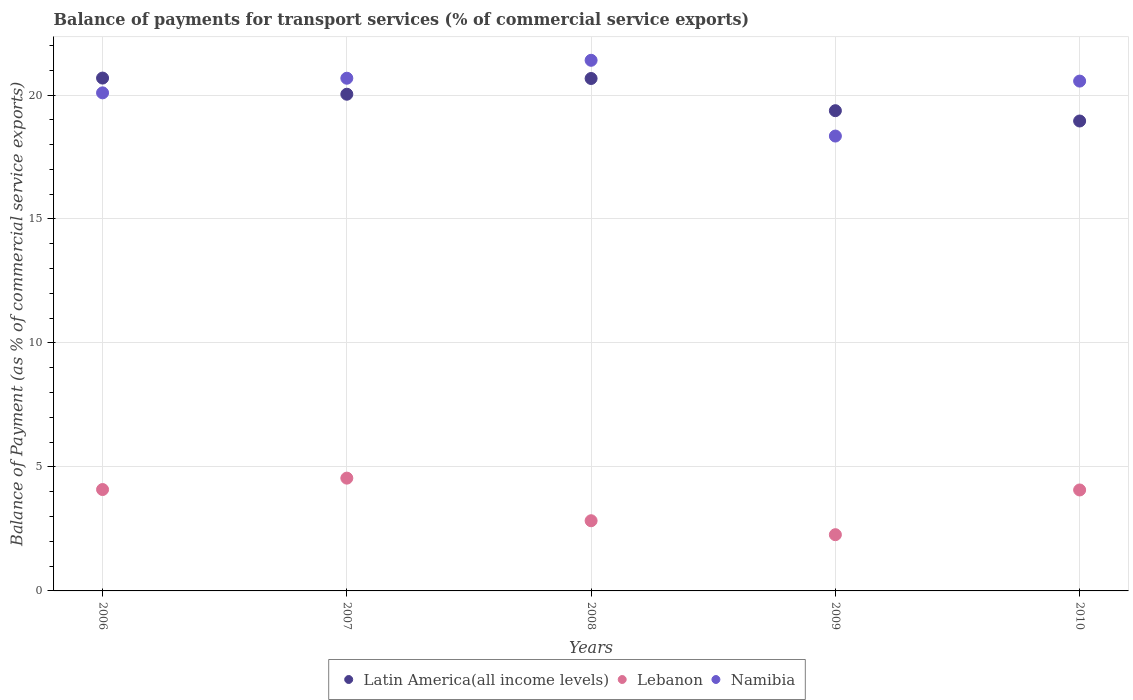Is the number of dotlines equal to the number of legend labels?
Your answer should be very brief. Yes. What is the balance of payments for transport services in Namibia in 2010?
Make the answer very short. 20.56. Across all years, what is the maximum balance of payments for transport services in Namibia?
Offer a terse response. 21.4. Across all years, what is the minimum balance of payments for transport services in Namibia?
Ensure brevity in your answer.  18.34. In which year was the balance of payments for transport services in Lebanon maximum?
Your response must be concise. 2007. In which year was the balance of payments for transport services in Namibia minimum?
Make the answer very short. 2009. What is the total balance of payments for transport services in Namibia in the graph?
Your answer should be very brief. 101.07. What is the difference between the balance of payments for transport services in Lebanon in 2008 and that in 2009?
Offer a terse response. 0.56. What is the difference between the balance of payments for transport services in Lebanon in 2007 and the balance of payments for transport services in Latin America(all income levels) in 2008?
Offer a very short reply. -16.12. What is the average balance of payments for transport services in Namibia per year?
Ensure brevity in your answer.  20.21. In the year 2010, what is the difference between the balance of payments for transport services in Namibia and balance of payments for transport services in Latin America(all income levels)?
Ensure brevity in your answer.  1.61. What is the ratio of the balance of payments for transport services in Namibia in 2006 to that in 2008?
Give a very brief answer. 0.94. Is the difference between the balance of payments for transport services in Namibia in 2008 and 2010 greater than the difference between the balance of payments for transport services in Latin America(all income levels) in 2008 and 2010?
Offer a terse response. No. What is the difference between the highest and the second highest balance of payments for transport services in Latin America(all income levels)?
Your answer should be very brief. 0.02. What is the difference between the highest and the lowest balance of payments for transport services in Lebanon?
Keep it short and to the point. 2.28. Does the balance of payments for transport services in Latin America(all income levels) monotonically increase over the years?
Your answer should be compact. No. Is the balance of payments for transport services in Namibia strictly greater than the balance of payments for transport services in Lebanon over the years?
Keep it short and to the point. Yes. Is the balance of payments for transport services in Namibia strictly less than the balance of payments for transport services in Latin America(all income levels) over the years?
Your response must be concise. No. How many dotlines are there?
Provide a succinct answer. 3. How many years are there in the graph?
Offer a terse response. 5. Does the graph contain any zero values?
Your response must be concise. No. Where does the legend appear in the graph?
Provide a short and direct response. Bottom center. How many legend labels are there?
Provide a succinct answer. 3. What is the title of the graph?
Your response must be concise. Balance of payments for transport services (% of commercial service exports). Does "Hong Kong" appear as one of the legend labels in the graph?
Give a very brief answer. No. What is the label or title of the X-axis?
Your answer should be very brief. Years. What is the label or title of the Y-axis?
Ensure brevity in your answer.  Balance of Payment (as % of commercial service exports). What is the Balance of Payment (as % of commercial service exports) in Latin America(all income levels) in 2006?
Your answer should be very brief. 20.68. What is the Balance of Payment (as % of commercial service exports) in Lebanon in 2006?
Ensure brevity in your answer.  4.09. What is the Balance of Payment (as % of commercial service exports) of Namibia in 2006?
Provide a succinct answer. 20.09. What is the Balance of Payment (as % of commercial service exports) of Latin America(all income levels) in 2007?
Your answer should be very brief. 20.03. What is the Balance of Payment (as % of commercial service exports) of Lebanon in 2007?
Keep it short and to the point. 4.55. What is the Balance of Payment (as % of commercial service exports) in Namibia in 2007?
Your response must be concise. 20.68. What is the Balance of Payment (as % of commercial service exports) of Latin America(all income levels) in 2008?
Your answer should be compact. 20.67. What is the Balance of Payment (as % of commercial service exports) in Lebanon in 2008?
Offer a very short reply. 2.83. What is the Balance of Payment (as % of commercial service exports) of Namibia in 2008?
Your answer should be compact. 21.4. What is the Balance of Payment (as % of commercial service exports) of Latin America(all income levels) in 2009?
Offer a very short reply. 19.37. What is the Balance of Payment (as % of commercial service exports) of Lebanon in 2009?
Your response must be concise. 2.27. What is the Balance of Payment (as % of commercial service exports) in Namibia in 2009?
Your answer should be compact. 18.34. What is the Balance of Payment (as % of commercial service exports) of Latin America(all income levels) in 2010?
Provide a succinct answer. 18.95. What is the Balance of Payment (as % of commercial service exports) of Lebanon in 2010?
Keep it short and to the point. 4.07. What is the Balance of Payment (as % of commercial service exports) of Namibia in 2010?
Provide a succinct answer. 20.56. Across all years, what is the maximum Balance of Payment (as % of commercial service exports) of Latin America(all income levels)?
Provide a succinct answer. 20.68. Across all years, what is the maximum Balance of Payment (as % of commercial service exports) in Lebanon?
Your response must be concise. 4.55. Across all years, what is the maximum Balance of Payment (as % of commercial service exports) of Namibia?
Your answer should be compact. 21.4. Across all years, what is the minimum Balance of Payment (as % of commercial service exports) in Latin America(all income levels)?
Make the answer very short. 18.95. Across all years, what is the minimum Balance of Payment (as % of commercial service exports) in Lebanon?
Your response must be concise. 2.27. Across all years, what is the minimum Balance of Payment (as % of commercial service exports) of Namibia?
Your response must be concise. 18.34. What is the total Balance of Payment (as % of commercial service exports) of Latin America(all income levels) in the graph?
Your answer should be compact. 99.7. What is the total Balance of Payment (as % of commercial service exports) in Lebanon in the graph?
Provide a short and direct response. 17.81. What is the total Balance of Payment (as % of commercial service exports) of Namibia in the graph?
Provide a succinct answer. 101.07. What is the difference between the Balance of Payment (as % of commercial service exports) of Latin America(all income levels) in 2006 and that in 2007?
Your answer should be very brief. 0.65. What is the difference between the Balance of Payment (as % of commercial service exports) in Lebanon in 2006 and that in 2007?
Ensure brevity in your answer.  -0.46. What is the difference between the Balance of Payment (as % of commercial service exports) of Namibia in 2006 and that in 2007?
Your answer should be very brief. -0.59. What is the difference between the Balance of Payment (as % of commercial service exports) of Latin America(all income levels) in 2006 and that in 2008?
Your answer should be compact. 0.02. What is the difference between the Balance of Payment (as % of commercial service exports) in Lebanon in 2006 and that in 2008?
Offer a terse response. 1.26. What is the difference between the Balance of Payment (as % of commercial service exports) in Namibia in 2006 and that in 2008?
Your answer should be compact. -1.31. What is the difference between the Balance of Payment (as % of commercial service exports) in Latin America(all income levels) in 2006 and that in 2009?
Your answer should be compact. 1.32. What is the difference between the Balance of Payment (as % of commercial service exports) in Lebanon in 2006 and that in 2009?
Make the answer very short. 1.82. What is the difference between the Balance of Payment (as % of commercial service exports) of Namibia in 2006 and that in 2009?
Provide a short and direct response. 1.74. What is the difference between the Balance of Payment (as % of commercial service exports) in Latin America(all income levels) in 2006 and that in 2010?
Offer a terse response. 1.73. What is the difference between the Balance of Payment (as % of commercial service exports) in Lebanon in 2006 and that in 2010?
Offer a very short reply. 0.02. What is the difference between the Balance of Payment (as % of commercial service exports) in Namibia in 2006 and that in 2010?
Your response must be concise. -0.47. What is the difference between the Balance of Payment (as % of commercial service exports) of Latin America(all income levels) in 2007 and that in 2008?
Provide a succinct answer. -0.63. What is the difference between the Balance of Payment (as % of commercial service exports) in Lebanon in 2007 and that in 2008?
Your response must be concise. 1.72. What is the difference between the Balance of Payment (as % of commercial service exports) in Namibia in 2007 and that in 2008?
Ensure brevity in your answer.  -0.72. What is the difference between the Balance of Payment (as % of commercial service exports) in Latin America(all income levels) in 2007 and that in 2009?
Ensure brevity in your answer.  0.66. What is the difference between the Balance of Payment (as % of commercial service exports) in Lebanon in 2007 and that in 2009?
Ensure brevity in your answer.  2.28. What is the difference between the Balance of Payment (as % of commercial service exports) in Namibia in 2007 and that in 2009?
Your response must be concise. 2.33. What is the difference between the Balance of Payment (as % of commercial service exports) of Latin America(all income levels) in 2007 and that in 2010?
Offer a terse response. 1.08. What is the difference between the Balance of Payment (as % of commercial service exports) of Lebanon in 2007 and that in 2010?
Provide a succinct answer. 0.48. What is the difference between the Balance of Payment (as % of commercial service exports) in Namibia in 2007 and that in 2010?
Ensure brevity in your answer.  0.12. What is the difference between the Balance of Payment (as % of commercial service exports) in Latin America(all income levels) in 2008 and that in 2009?
Keep it short and to the point. 1.3. What is the difference between the Balance of Payment (as % of commercial service exports) in Lebanon in 2008 and that in 2009?
Provide a succinct answer. 0.56. What is the difference between the Balance of Payment (as % of commercial service exports) of Namibia in 2008 and that in 2009?
Offer a very short reply. 3.06. What is the difference between the Balance of Payment (as % of commercial service exports) of Latin America(all income levels) in 2008 and that in 2010?
Your response must be concise. 1.71. What is the difference between the Balance of Payment (as % of commercial service exports) of Lebanon in 2008 and that in 2010?
Provide a short and direct response. -1.24. What is the difference between the Balance of Payment (as % of commercial service exports) in Namibia in 2008 and that in 2010?
Offer a very short reply. 0.84. What is the difference between the Balance of Payment (as % of commercial service exports) of Latin America(all income levels) in 2009 and that in 2010?
Your answer should be very brief. 0.42. What is the difference between the Balance of Payment (as % of commercial service exports) of Lebanon in 2009 and that in 2010?
Offer a terse response. -1.8. What is the difference between the Balance of Payment (as % of commercial service exports) of Namibia in 2009 and that in 2010?
Your response must be concise. -2.22. What is the difference between the Balance of Payment (as % of commercial service exports) of Latin America(all income levels) in 2006 and the Balance of Payment (as % of commercial service exports) of Lebanon in 2007?
Keep it short and to the point. 16.13. What is the difference between the Balance of Payment (as % of commercial service exports) in Latin America(all income levels) in 2006 and the Balance of Payment (as % of commercial service exports) in Namibia in 2007?
Your answer should be very brief. 0.01. What is the difference between the Balance of Payment (as % of commercial service exports) of Lebanon in 2006 and the Balance of Payment (as % of commercial service exports) of Namibia in 2007?
Your answer should be very brief. -16.59. What is the difference between the Balance of Payment (as % of commercial service exports) in Latin America(all income levels) in 2006 and the Balance of Payment (as % of commercial service exports) in Lebanon in 2008?
Keep it short and to the point. 17.85. What is the difference between the Balance of Payment (as % of commercial service exports) of Latin America(all income levels) in 2006 and the Balance of Payment (as % of commercial service exports) of Namibia in 2008?
Keep it short and to the point. -0.72. What is the difference between the Balance of Payment (as % of commercial service exports) of Lebanon in 2006 and the Balance of Payment (as % of commercial service exports) of Namibia in 2008?
Ensure brevity in your answer.  -17.31. What is the difference between the Balance of Payment (as % of commercial service exports) in Latin America(all income levels) in 2006 and the Balance of Payment (as % of commercial service exports) in Lebanon in 2009?
Make the answer very short. 18.42. What is the difference between the Balance of Payment (as % of commercial service exports) of Latin America(all income levels) in 2006 and the Balance of Payment (as % of commercial service exports) of Namibia in 2009?
Keep it short and to the point. 2.34. What is the difference between the Balance of Payment (as % of commercial service exports) in Lebanon in 2006 and the Balance of Payment (as % of commercial service exports) in Namibia in 2009?
Your response must be concise. -14.26. What is the difference between the Balance of Payment (as % of commercial service exports) of Latin America(all income levels) in 2006 and the Balance of Payment (as % of commercial service exports) of Lebanon in 2010?
Your response must be concise. 16.61. What is the difference between the Balance of Payment (as % of commercial service exports) in Latin America(all income levels) in 2006 and the Balance of Payment (as % of commercial service exports) in Namibia in 2010?
Your answer should be very brief. 0.12. What is the difference between the Balance of Payment (as % of commercial service exports) of Lebanon in 2006 and the Balance of Payment (as % of commercial service exports) of Namibia in 2010?
Your response must be concise. -16.47. What is the difference between the Balance of Payment (as % of commercial service exports) of Latin America(all income levels) in 2007 and the Balance of Payment (as % of commercial service exports) of Lebanon in 2008?
Your response must be concise. 17.2. What is the difference between the Balance of Payment (as % of commercial service exports) in Latin America(all income levels) in 2007 and the Balance of Payment (as % of commercial service exports) in Namibia in 2008?
Ensure brevity in your answer.  -1.37. What is the difference between the Balance of Payment (as % of commercial service exports) of Lebanon in 2007 and the Balance of Payment (as % of commercial service exports) of Namibia in 2008?
Offer a very short reply. -16.85. What is the difference between the Balance of Payment (as % of commercial service exports) in Latin America(all income levels) in 2007 and the Balance of Payment (as % of commercial service exports) in Lebanon in 2009?
Offer a very short reply. 17.76. What is the difference between the Balance of Payment (as % of commercial service exports) in Latin America(all income levels) in 2007 and the Balance of Payment (as % of commercial service exports) in Namibia in 2009?
Give a very brief answer. 1.69. What is the difference between the Balance of Payment (as % of commercial service exports) in Lebanon in 2007 and the Balance of Payment (as % of commercial service exports) in Namibia in 2009?
Keep it short and to the point. -13.8. What is the difference between the Balance of Payment (as % of commercial service exports) of Latin America(all income levels) in 2007 and the Balance of Payment (as % of commercial service exports) of Lebanon in 2010?
Ensure brevity in your answer.  15.96. What is the difference between the Balance of Payment (as % of commercial service exports) of Latin America(all income levels) in 2007 and the Balance of Payment (as % of commercial service exports) of Namibia in 2010?
Your answer should be very brief. -0.53. What is the difference between the Balance of Payment (as % of commercial service exports) of Lebanon in 2007 and the Balance of Payment (as % of commercial service exports) of Namibia in 2010?
Your response must be concise. -16.01. What is the difference between the Balance of Payment (as % of commercial service exports) of Latin America(all income levels) in 2008 and the Balance of Payment (as % of commercial service exports) of Lebanon in 2009?
Your response must be concise. 18.4. What is the difference between the Balance of Payment (as % of commercial service exports) in Latin America(all income levels) in 2008 and the Balance of Payment (as % of commercial service exports) in Namibia in 2009?
Offer a terse response. 2.32. What is the difference between the Balance of Payment (as % of commercial service exports) of Lebanon in 2008 and the Balance of Payment (as % of commercial service exports) of Namibia in 2009?
Keep it short and to the point. -15.51. What is the difference between the Balance of Payment (as % of commercial service exports) in Latin America(all income levels) in 2008 and the Balance of Payment (as % of commercial service exports) in Lebanon in 2010?
Keep it short and to the point. 16.59. What is the difference between the Balance of Payment (as % of commercial service exports) in Latin America(all income levels) in 2008 and the Balance of Payment (as % of commercial service exports) in Namibia in 2010?
Ensure brevity in your answer.  0.1. What is the difference between the Balance of Payment (as % of commercial service exports) of Lebanon in 2008 and the Balance of Payment (as % of commercial service exports) of Namibia in 2010?
Your response must be concise. -17.73. What is the difference between the Balance of Payment (as % of commercial service exports) in Latin America(all income levels) in 2009 and the Balance of Payment (as % of commercial service exports) in Lebanon in 2010?
Your answer should be very brief. 15.3. What is the difference between the Balance of Payment (as % of commercial service exports) of Latin America(all income levels) in 2009 and the Balance of Payment (as % of commercial service exports) of Namibia in 2010?
Make the answer very short. -1.19. What is the difference between the Balance of Payment (as % of commercial service exports) of Lebanon in 2009 and the Balance of Payment (as % of commercial service exports) of Namibia in 2010?
Your answer should be very brief. -18.29. What is the average Balance of Payment (as % of commercial service exports) in Latin America(all income levels) per year?
Make the answer very short. 19.94. What is the average Balance of Payment (as % of commercial service exports) in Lebanon per year?
Keep it short and to the point. 3.56. What is the average Balance of Payment (as % of commercial service exports) of Namibia per year?
Ensure brevity in your answer.  20.21. In the year 2006, what is the difference between the Balance of Payment (as % of commercial service exports) in Latin America(all income levels) and Balance of Payment (as % of commercial service exports) in Lebanon?
Give a very brief answer. 16.59. In the year 2006, what is the difference between the Balance of Payment (as % of commercial service exports) in Latin America(all income levels) and Balance of Payment (as % of commercial service exports) in Namibia?
Your answer should be very brief. 0.6. In the year 2006, what is the difference between the Balance of Payment (as % of commercial service exports) in Lebanon and Balance of Payment (as % of commercial service exports) in Namibia?
Ensure brevity in your answer.  -16. In the year 2007, what is the difference between the Balance of Payment (as % of commercial service exports) of Latin America(all income levels) and Balance of Payment (as % of commercial service exports) of Lebanon?
Make the answer very short. 15.48. In the year 2007, what is the difference between the Balance of Payment (as % of commercial service exports) in Latin America(all income levels) and Balance of Payment (as % of commercial service exports) in Namibia?
Provide a succinct answer. -0.65. In the year 2007, what is the difference between the Balance of Payment (as % of commercial service exports) in Lebanon and Balance of Payment (as % of commercial service exports) in Namibia?
Offer a terse response. -16.13. In the year 2008, what is the difference between the Balance of Payment (as % of commercial service exports) in Latin America(all income levels) and Balance of Payment (as % of commercial service exports) in Lebanon?
Give a very brief answer. 17.84. In the year 2008, what is the difference between the Balance of Payment (as % of commercial service exports) in Latin America(all income levels) and Balance of Payment (as % of commercial service exports) in Namibia?
Your answer should be compact. -0.73. In the year 2008, what is the difference between the Balance of Payment (as % of commercial service exports) in Lebanon and Balance of Payment (as % of commercial service exports) in Namibia?
Provide a succinct answer. -18.57. In the year 2009, what is the difference between the Balance of Payment (as % of commercial service exports) of Latin America(all income levels) and Balance of Payment (as % of commercial service exports) of Lebanon?
Your answer should be compact. 17.1. In the year 2009, what is the difference between the Balance of Payment (as % of commercial service exports) of Latin America(all income levels) and Balance of Payment (as % of commercial service exports) of Namibia?
Keep it short and to the point. 1.02. In the year 2009, what is the difference between the Balance of Payment (as % of commercial service exports) of Lebanon and Balance of Payment (as % of commercial service exports) of Namibia?
Keep it short and to the point. -16.08. In the year 2010, what is the difference between the Balance of Payment (as % of commercial service exports) in Latin America(all income levels) and Balance of Payment (as % of commercial service exports) in Lebanon?
Ensure brevity in your answer.  14.88. In the year 2010, what is the difference between the Balance of Payment (as % of commercial service exports) of Latin America(all income levels) and Balance of Payment (as % of commercial service exports) of Namibia?
Give a very brief answer. -1.61. In the year 2010, what is the difference between the Balance of Payment (as % of commercial service exports) of Lebanon and Balance of Payment (as % of commercial service exports) of Namibia?
Provide a short and direct response. -16.49. What is the ratio of the Balance of Payment (as % of commercial service exports) of Latin America(all income levels) in 2006 to that in 2007?
Your response must be concise. 1.03. What is the ratio of the Balance of Payment (as % of commercial service exports) in Lebanon in 2006 to that in 2007?
Offer a very short reply. 0.9. What is the ratio of the Balance of Payment (as % of commercial service exports) in Namibia in 2006 to that in 2007?
Your answer should be compact. 0.97. What is the ratio of the Balance of Payment (as % of commercial service exports) of Lebanon in 2006 to that in 2008?
Your response must be concise. 1.44. What is the ratio of the Balance of Payment (as % of commercial service exports) of Namibia in 2006 to that in 2008?
Provide a succinct answer. 0.94. What is the ratio of the Balance of Payment (as % of commercial service exports) of Latin America(all income levels) in 2006 to that in 2009?
Your response must be concise. 1.07. What is the ratio of the Balance of Payment (as % of commercial service exports) of Lebanon in 2006 to that in 2009?
Provide a succinct answer. 1.8. What is the ratio of the Balance of Payment (as % of commercial service exports) of Namibia in 2006 to that in 2009?
Ensure brevity in your answer.  1.09. What is the ratio of the Balance of Payment (as % of commercial service exports) of Latin America(all income levels) in 2006 to that in 2010?
Offer a terse response. 1.09. What is the ratio of the Balance of Payment (as % of commercial service exports) of Lebanon in 2006 to that in 2010?
Your response must be concise. 1. What is the ratio of the Balance of Payment (as % of commercial service exports) of Namibia in 2006 to that in 2010?
Your answer should be compact. 0.98. What is the ratio of the Balance of Payment (as % of commercial service exports) of Latin America(all income levels) in 2007 to that in 2008?
Keep it short and to the point. 0.97. What is the ratio of the Balance of Payment (as % of commercial service exports) in Lebanon in 2007 to that in 2008?
Ensure brevity in your answer.  1.61. What is the ratio of the Balance of Payment (as % of commercial service exports) in Namibia in 2007 to that in 2008?
Your response must be concise. 0.97. What is the ratio of the Balance of Payment (as % of commercial service exports) of Latin America(all income levels) in 2007 to that in 2009?
Offer a terse response. 1.03. What is the ratio of the Balance of Payment (as % of commercial service exports) of Lebanon in 2007 to that in 2009?
Your answer should be compact. 2.01. What is the ratio of the Balance of Payment (as % of commercial service exports) of Namibia in 2007 to that in 2009?
Ensure brevity in your answer.  1.13. What is the ratio of the Balance of Payment (as % of commercial service exports) in Latin America(all income levels) in 2007 to that in 2010?
Provide a succinct answer. 1.06. What is the ratio of the Balance of Payment (as % of commercial service exports) in Lebanon in 2007 to that in 2010?
Ensure brevity in your answer.  1.12. What is the ratio of the Balance of Payment (as % of commercial service exports) in Namibia in 2007 to that in 2010?
Offer a very short reply. 1.01. What is the ratio of the Balance of Payment (as % of commercial service exports) in Latin America(all income levels) in 2008 to that in 2009?
Your answer should be compact. 1.07. What is the ratio of the Balance of Payment (as % of commercial service exports) of Lebanon in 2008 to that in 2009?
Your answer should be very brief. 1.25. What is the ratio of the Balance of Payment (as % of commercial service exports) of Namibia in 2008 to that in 2009?
Make the answer very short. 1.17. What is the ratio of the Balance of Payment (as % of commercial service exports) in Latin America(all income levels) in 2008 to that in 2010?
Provide a succinct answer. 1.09. What is the ratio of the Balance of Payment (as % of commercial service exports) of Lebanon in 2008 to that in 2010?
Provide a succinct answer. 0.7. What is the ratio of the Balance of Payment (as % of commercial service exports) of Namibia in 2008 to that in 2010?
Your response must be concise. 1.04. What is the ratio of the Balance of Payment (as % of commercial service exports) in Latin America(all income levels) in 2009 to that in 2010?
Offer a terse response. 1.02. What is the ratio of the Balance of Payment (as % of commercial service exports) of Lebanon in 2009 to that in 2010?
Offer a terse response. 0.56. What is the ratio of the Balance of Payment (as % of commercial service exports) in Namibia in 2009 to that in 2010?
Offer a very short reply. 0.89. What is the difference between the highest and the second highest Balance of Payment (as % of commercial service exports) of Latin America(all income levels)?
Keep it short and to the point. 0.02. What is the difference between the highest and the second highest Balance of Payment (as % of commercial service exports) in Lebanon?
Offer a very short reply. 0.46. What is the difference between the highest and the second highest Balance of Payment (as % of commercial service exports) in Namibia?
Ensure brevity in your answer.  0.72. What is the difference between the highest and the lowest Balance of Payment (as % of commercial service exports) of Latin America(all income levels)?
Your answer should be very brief. 1.73. What is the difference between the highest and the lowest Balance of Payment (as % of commercial service exports) in Lebanon?
Make the answer very short. 2.28. What is the difference between the highest and the lowest Balance of Payment (as % of commercial service exports) in Namibia?
Offer a terse response. 3.06. 